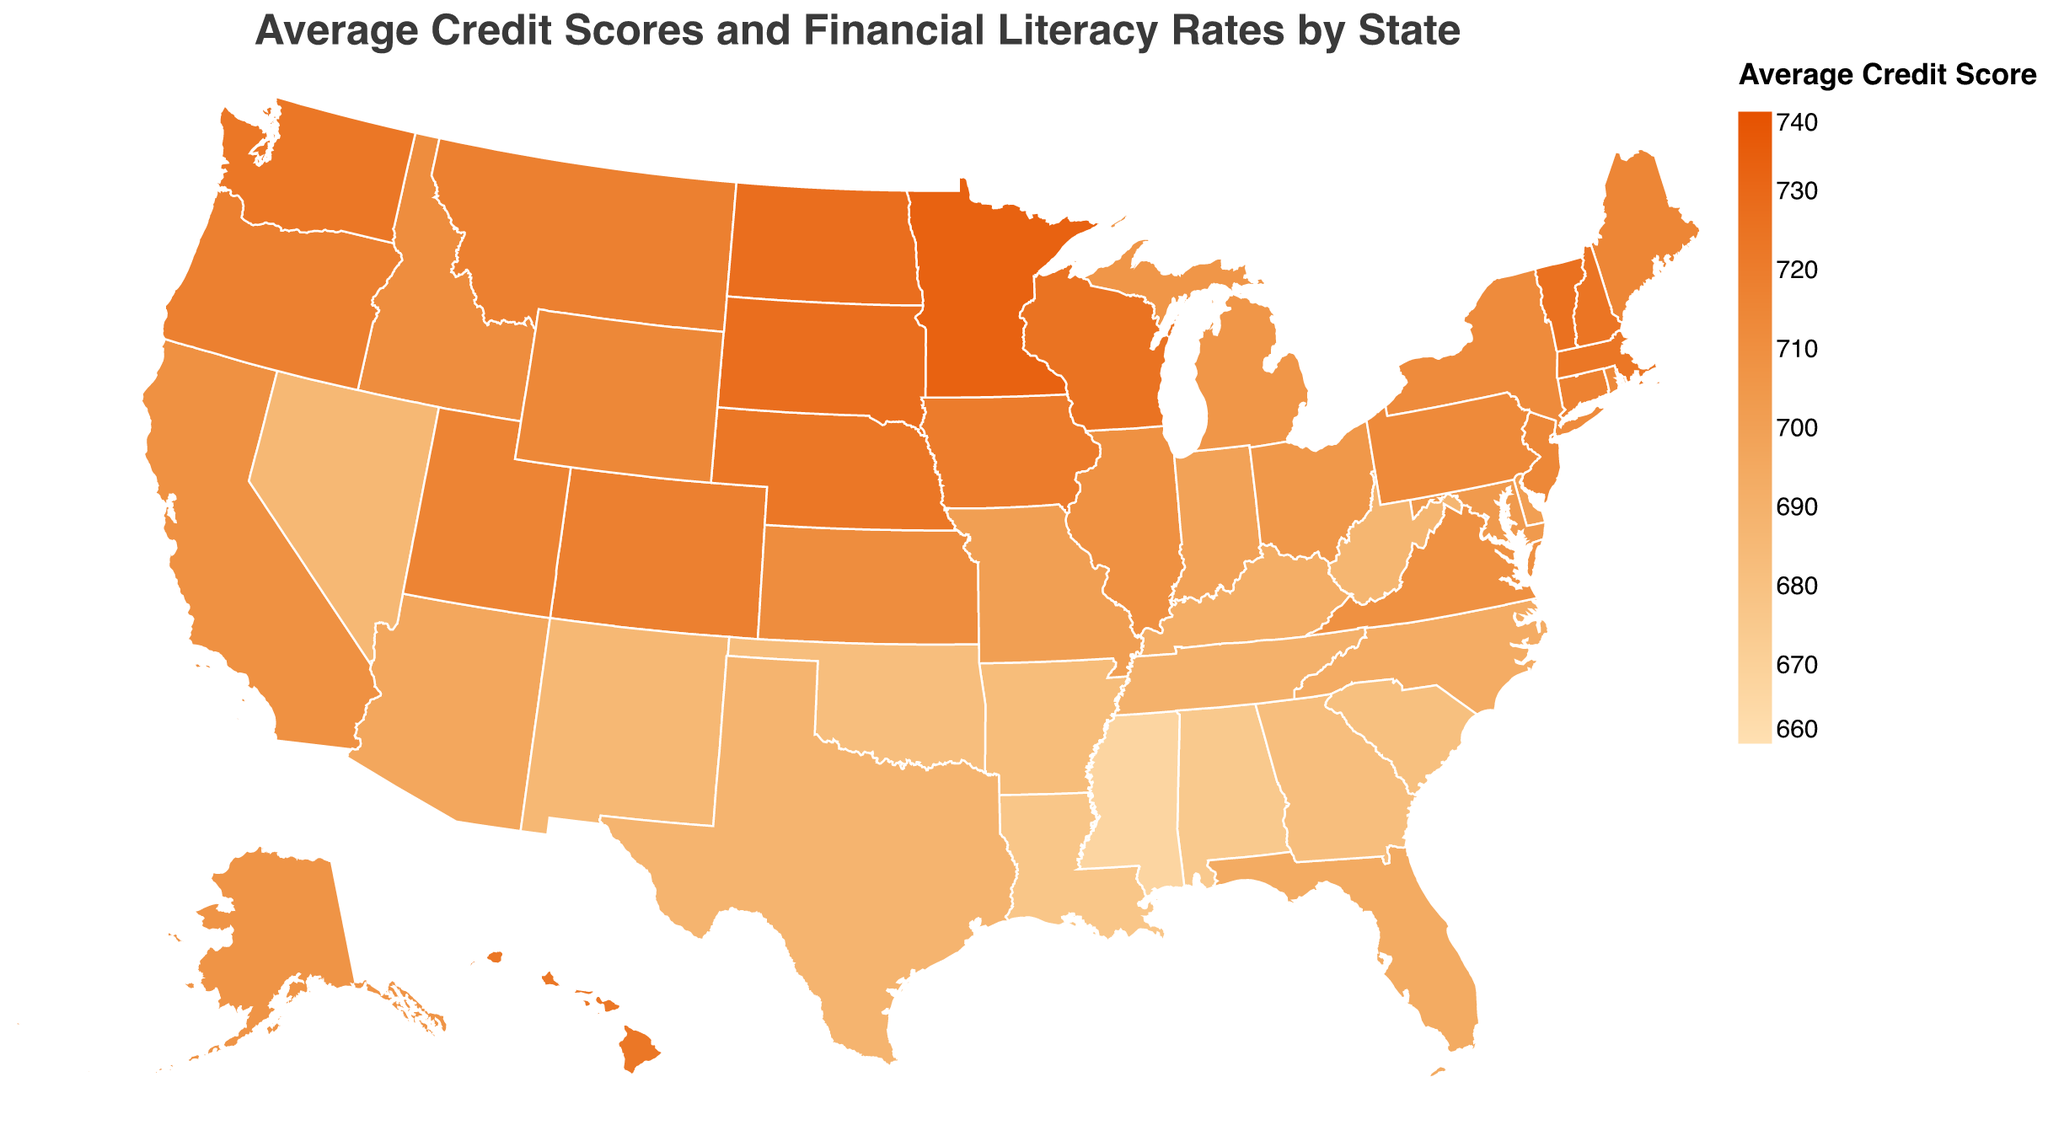What is the title of the figure? The title is located at the top of the figure and usually highlights the main topic or content being displayed. The title here reads "Average Credit Scores and Financial Literacy Rates by State".
Answer: Average Credit Scores and Financial Literacy Rates by State Which state has the highest average credit score? By looking at the color gradient in the figure, the darkest shade will indicate the highest credit score. According to the tooltip, Minnesota has the highest average credit score.
Answer: Minnesota What is the financial literacy rate of California? Hovering over or checking the tooltip for California, it shows the financial literacy rate of 64%.
Answer: 64% Which states have an average credit score higher than 720? By examining the color gradient and the tooltip information for each state, we can identify states with scores higher than 720: Hawaii, Iowa, Massachusetts, Nebraska, North Dakota, South Dakota, Utah, Vermont, Washington, and Wisconsin.
Answer: Hawaii, Iowa, Massachusetts, Nebraska, North Dakota, South Dakota, Utah, Vermont, Washington, Wisconsin What is the average credit score and financial literacy rate for Texas? By referring to the tooltip information for Texas, both the average credit score and the financial literacy rate are displayed. Texas has an average credit score of 688 and a financial literacy rate of 59%.
Answer: 688, 59% Is there a correlation between high financial literacy rates and high average credit scores? To determine this, you would look for states with both high financial literacy rates (typically above 65%) and high credit scores (typically above 700). Examples include Minnesota, Vermont, and Nebraska, which suggest a correlation.
Answer: Yes How does Wyoming’s average credit score compare to its financial literacy rate? The tooltip information for Wyoming reveals that its average credit score is 714 while the financial literacy rate is 64%. This suggests that while the state has a higher credit score, its financial literacy rate is moderately high.
Answer: 714 compared to 64% Which states have both lower than average credit score and financial literacy rate? By identifying the states with lighter shades and checking their tooltip information, states like Mississippi (667, 55) and Arkansas (683, 56) have both lower than average credit scores and financial literacy rates.
Answer: Mississippi, Arkansas What is the difference in financial literacy rates between Massachusetts and Alabama? The financial literacy rate for Massachusetts is 70%, and for Alabama, it is 58%. The difference is calculated as 70 - 58 = 12%.
Answer: 12% Which state has the closest average credit score to 700? Hovering over the states and checking the tooltip information reveals that Delaware and Missouri have an average credit score closest to 700, both at 701.
Answer: Delaware, Missouri 